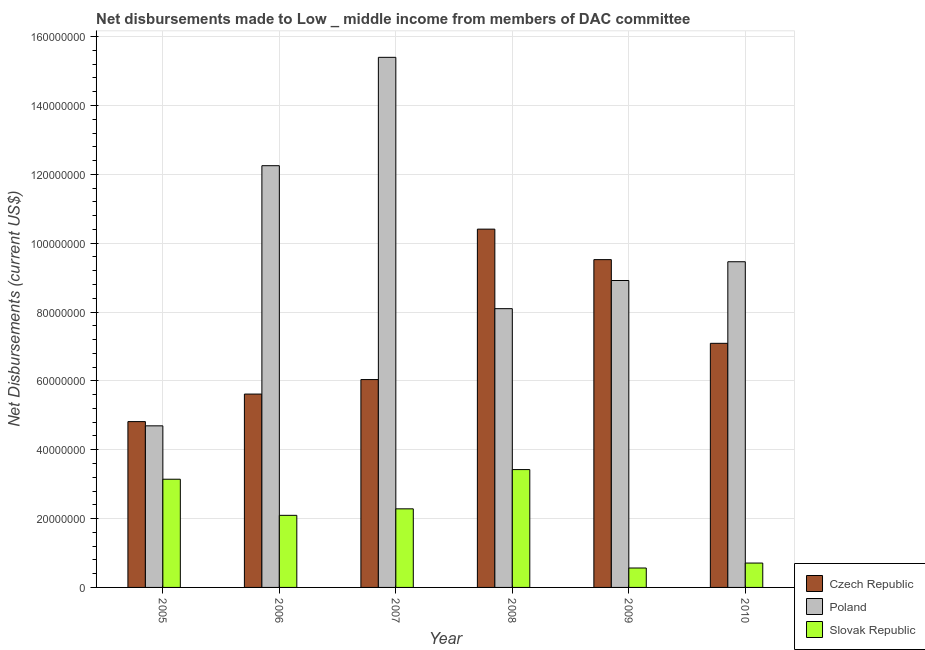Are the number of bars per tick equal to the number of legend labels?
Provide a short and direct response. Yes. Are the number of bars on each tick of the X-axis equal?
Your answer should be very brief. Yes. How many bars are there on the 5th tick from the left?
Give a very brief answer. 3. How many bars are there on the 1st tick from the right?
Your answer should be very brief. 3. What is the label of the 6th group of bars from the left?
Ensure brevity in your answer.  2010. What is the net disbursements made by poland in 2008?
Offer a terse response. 8.10e+07. Across all years, what is the maximum net disbursements made by poland?
Ensure brevity in your answer.  1.54e+08. Across all years, what is the minimum net disbursements made by poland?
Make the answer very short. 4.69e+07. In which year was the net disbursements made by czech republic maximum?
Keep it short and to the point. 2008. What is the total net disbursements made by czech republic in the graph?
Your answer should be compact. 4.35e+08. What is the difference between the net disbursements made by poland in 2009 and that in 2010?
Offer a very short reply. -5.45e+06. What is the difference between the net disbursements made by czech republic in 2010 and the net disbursements made by poland in 2007?
Your answer should be compact. 1.05e+07. What is the average net disbursements made by slovak republic per year?
Give a very brief answer. 2.04e+07. What is the ratio of the net disbursements made by slovak republic in 2008 to that in 2010?
Your response must be concise. 4.83. Is the net disbursements made by slovak republic in 2006 less than that in 2008?
Your answer should be compact. Yes. Is the difference between the net disbursements made by slovak republic in 2008 and 2009 greater than the difference between the net disbursements made by poland in 2008 and 2009?
Ensure brevity in your answer.  No. What is the difference between the highest and the second highest net disbursements made by poland?
Offer a terse response. 3.15e+07. What is the difference between the highest and the lowest net disbursements made by poland?
Keep it short and to the point. 1.07e+08. What does the 3rd bar from the left in 2009 represents?
Your answer should be very brief. Slovak Republic. What does the 3rd bar from the right in 2005 represents?
Provide a succinct answer. Czech Republic. Are all the bars in the graph horizontal?
Provide a short and direct response. No. Does the graph contain any zero values?
Make the answer very short. No. Where does the legend appear in the graph?
Keep it short and to the point. Bottom right. How many legend labels are there?
Your answer should be compact. 3. What is the title of the graph?
Give a very brief answer. Net disbursements made to Low _ middle income from members of DAC committee. What is the label or title of the Y-axis?
Your response must be concise. Net Disbursements (current US$). What is the Net Disbursements (current US$) in Czech Republic in 2005?
Your answer should be compact. 4.82e+07. What is the Net Disbursements (current US$) of Poland in 2005?
Your response must be concise. 4.69e+07. What is the Net Disbursements (current US$) of Slovak Republic in 2005?
Offer a terse response. 3.14e+07. What is the Net Disbursements (current US$) of Czech Republic in 2006?
Your answer should be very brief. 5.62e+07. What is the Net Disbursements (current US$) of Poland in 2006?
Offer a terse response. 1.23e+08. What is the Net Disbursements (current US$) of Slovak Republic in 2006?
Keep it short and to the point. 2.09e+07. What is the Net Disbursements (current US$) in Czech Republic in 2007?
Make the answer very short. 6.04e+07. What is the Net Disbursements (current US$) in Poland in 2007?
Your answer should be compact. 1.54e+08. What is the Net Disbursements (current US$) in Slovak Republic in 2007?
Ensure brevity in your answer.  2.28e+07. What is the Net Disbursements (current US$) of Czech Republic in 2008?
Give a very brief answer. 1.04e+08. What is the Net Disbursements (current US$) of Poland in 2008?
Give a very brief answer. 8.10e+07. What is the Net Disbursements (current US$) of Slovak Republic in 2008?
Keep it short and to the point. 3.42e+07. What is the Net Disbursements (current US$) of Czech Republic in 2009?
Offer a very short reply. 9.52e+07. What is the Net Disbursements (current US$) in Poland in 2009?
Make the answer very short. 8.92e+07. What is the Net Disbursements (current US$) in Slovak Republic in 2009?
Offer a terse response. 5.64e+06. What is the Net Disbursements (current US$) in Czech Republic in 2010?
Keep it short and to the point. 7.09e+07. What is the Net Disbursements (current US$) of Poland in 2010?
Make the answer very short. 9.46e+07. What is the Net Disbursements (current US$) of Slovak Republic in 2010?
Make the answer very short. 7.08e+06. Across all years, what is the maximum Net Disbursements (current US$) in Czech Republic?
Ensure brevity in your answer.  1.04e+08. Across all years, what is the maximum Net Disbursements (current US$) in Poland?
Your answer should be very brief. 1.54e+08. Across all years, what is the maximum Net Disbursements (current US$) of Slovak Republic?
Keep it short and to the point. 3.42e+07. Across all years, what is the minimum Net Disbursements (current US$) of Czech Republic?
Ensure brevity in your answer.  4.82e+07. Across all years, what is the minimum Net Disbursements (current US$) of Poland?
Provide a short and direct response. 4.69e+07. Across all years, what is the minimum Net Disbursements (current US$) of Slovak Republic?
Your answer should be very brief. 5.64e+06. What is the total Net Disbursements (current US$) in Czech Republic in the graph?
Provide a succinct answer. 4.35e+08. What is the total Net Disbursements (current US$) of Poland in the graph?
Your answer should be compact. 5.88e+08. What is the total Net Disbursements (current US$) in Slovak Republic in the graph?
Offer a very short reply. 1.22e+08. What is the difference between the Net Disbursements (current US$) in Czech Republic in 2005 and that in 2006?
Your answer should be very brief. -8.00e+06. What is the difference between the Net Disbursements (current US$) of Poland in 2005 and that in 2006?
Ensure brevity in your answer.  -7.56e+07. What is the difference between the Net Disbursements (current US$) in Slovak Republic in 2005 and that in 2006?
Offer a terse response. 1.05e+07. What is the difference between the Net Disbursements (current US$) in Czech Republic in 2005 and that in 2007?
Provide a succinct answer. -1.22e+07. What is the difference between the Net Disbursements (current US$) of Poland in 2005 and that in 2007?
Keep it short and to the point. -1.07e+08. What is the difference between the Net Disbursements (current US$) of Slovak Republic in 2005 and that in 2007?
Ensure brevity in your answer.  8.60e+06. What is the difference between the Net Disbursements (current US$) of Czech Republic in 2005 and that in 2008?
Keep it short and to the point. -5.59e+07. What is the difference between the Net Disbursements (current US$) in Poland in 2005 and that in 2008?
Your answer should be compact. -3.40e+07. What is the difference between the Net Disbursements (current US$) in Slovak Republic in 2005 and that in 2008?
Keep it short and to the point. -2.80e+06. What is the difference between the Net Disbursements (current US$) in Czech Republic in 2005 and that in 2009?
Your answer should be very brief. -4.70e+07. What is the difference between the Net Disbursements (current US$) of Poland in 2005 and that in 2009?
Give a very brief answer. -4.22e+07. What is the difference between the Net Disbursements (current US$) of Slovak Republic in 2005 and that in 2009?
Provide a succinct answer. 2.58e+07. What is the difference between the Net Disbursements (current US$) of Czech Republic in 2005 and that in 2010?
Provide a succinct answer. -2.27e+07. What is the difference between the Net Disbursements (current US$) in Poland in 2005 and that in 2010?
Make the answer very short. -4.77e+07. What is the difference between the Net Disbursements (current US$) of Slovak Republic in 2005 and that in 2010?
Your answer should be very brief. 2.44e+07. What is the difference between the Net Disbursements (current US$) of Czech Republic in 2006 and that in 2007?
Keep it short and to the point. -4.21e+06. What is the difference between the Net Disbursements (current US$) of Poland in 2006 and that in 2007?
Keep it short and to the point. -3.15e+07. What is the difference between the Net Disbursements (current US$) of Slovak Republic in 2006 and that in 2007?
Keep it short and to the point. -1.89e+06. What is the difference between the Net Disbursements (current US$) in Czech Republic in 2006 and that in 2008?
Make the answer very short. -4.79e+07. What is the difference between the Net Disbursements (current US$) of Poland in 2006 and that in 2008?
Ensure brevity in your answer.  4.15e+07. What is the difference between the Net Disbursements (current US$) in Slovak Republic in 2006 and that in 2008?
Offer a very short reply. -1.33e+07. What is the difference between the Net Disbursements (current US$) of Czech Republic in 2006 and that in 2009?
Provide a short and direct response. -3.90e+07. What is the difference between the Net Disbursements (current US$) of Poland in 2006 and that in 2009?
Your response must be concise. 3.34e+07. What is the difference between the Net Disbursements (current US$) in Slovak Republic in 2006 and that in 2009?
Your answer should be very brief. 1.53e+07. What is the difference between the Net Disbursements (current US$) in Czech Republic in 2006 and that in 2010?
Give a very brief answer. -1.47e+07. What is the difference between the Net Disbursements (current US$) of Poland in 2006 and that in 2010?
Keep it short and to the point. 2.79e+07. What is the difference between the Net Disbursements (current US$) of Slovak Republic in 2006 and that in 2010?
Make the answer very short. 1.39e+07. What is the difference between the Net Disbursements (current US$) of Czech Republic in 2007 and that in 2008?
Your answer should be very brief. -4.37e+07. What is the difference between the Net Disbursements (current US$) in Poland in 2007 and that in 2008?
Your answer should be compact. 7.30e+07. What is the difference between the Net Disbursements (current US$) in Slovak Republic in 2007 and that in 2008?
Offer a terse response. -1.14e+07. What is the difference between the Net Disbursements (current US$) in Czech Republic in 2007 and that in 2009?
Offer a terse response. -3.48e+07. What is the difference between the Net Disbursements (current US$) of Poland in 2007 and that in 2009?
Provide a succinct answer. 6.48e+07. What is the difference between the Net Disbursements (current US$) of Slovak Republic in 2007 and that in 2009?
Give a very brief answer. 1.72e+07. What is the difference between the Net Disbursements (current US$) of Czech Republic in 2007 and that in 2010?
Keep it short and to the point. -1.05e+07. What is the difference between the Net Disbursements (current US$) of Poland in 2007 and that in 2010?
Ensure brevity in your answer.  5.94e+07. What is the difference between the Net Disbursements (current US$) of Slovak Republic in 2007 and that in 2010?
Keep it short and to the point. 1.58e+07. What is the difference between the Net Disbursements (current US$) of Czech Republic in 2008 and that in 2009?
Your answer should be very brief. 8.86e+06. What is the difference between the Net Disbursements (current US$) in Poland in 2008 and that in 2009?
Your answer should be compact. -8.18e+06. What is the difference between the Net Disbursements (current US$) of Slovak Republic in 2008 and that in 2009?
Keep it short and to the point. 2.86e+07. What is the difference between the Net Disbursements (current US$) of Czech Republic in 2008 and that in 2010?
Provide a succinct answer. 3.32e+07. What is the difference between the Net Disbursements (current US$) of Poland in 2008 and that in 2010?
Give a very brief answer. -1.36e+07. What is the difference between the Net Disbursements (current US$) of Slovak Republic in 2008 and that in 2010?
Keep it short and to the point. 2.72e+07. What is the difference between the Net Disbursements (current US$) in Czech Republic in 2009 and that in 2010?
Make the answer very short. 2.43e+07. What is the difference between the Net Disbursements (current US$) of Poland in 2009 and that in 2010?
Your answer should be compact. -5.45e+06. What is the difference between the Net Disbursements (current US$) in Slovak Republic in 2009 and that in 2010?
Your answer should be very brief. -1.44e+06. What is the difference between the Net Disbursements (current US$) of Czech Republic in 2005 and the Net Disbursements (current US$) of Poland in 2006?
Your answer should be very brief. -7.43e+07. What is the difference between the Net Disbursements (current US$) in Czech Republic in 2005 and the Net Disbursements (current US$) in Slovak Republic in 2006?
Make the answer very short. 2.72e+07. What is the difference between the Net Disbursements (current US$) of Poland in 2005 and the Net Disbursements (current US$) of Slovak Republic in 2006?
Your response must be concise. 2.60e+07. What is the difference between the Net Disbursements (current US$) of Czech Republic in 2005 and the Net Disbursements (current US$) of Poland in 2007?
Ensure brevity in your answer.  -1.06e+08. What is the difference between the Net Disbursements (current US$) of Czech Republic in 2005 and the Net Disbursements (current US$) of Slovak Republic in 2007?
Ensure brevity in your answer.  2.53e+07. What is the difference between the Net Disbursements (current US$) in Poland in 2005 and the Net Disbursements (current US$) in Slovak Republic in 2007?
Your answer should be very brief. 2.41e+07. What is the difference between the Net Disbursements (current US$) in Czech Republic in 2005 and the Net Disbursements (current US$) in Poland in 2008?
Give a very brief answer. -3.28e+07. What is the difference between the Net Disbursements (current US$) of Czech Republic in 2005 and the Net Disbursements (current US$) of Slovak Republic in 2008?
Your response must be concise. 1.39e+07. What is the difference between the Net Disbursements (current US$) in Poland in 2005 and the Net Disbursements (current US$) in Slovak Republic in 2008?
Your response must be concise. 1.27e+07. What is the difference between the Net Disbursements (current US$) of Czech Republic in 2005 and the Net Disbursements (current US$) of Poland in 2009?
Provide a short and direct response. -4.10e+07. What is the difference between the Net Disbursements (current US$) in Czech Republic in 2005 and the Net Disbursements (current US$) in Slovak Republic in 2009?
Keep it short and to the point. 4.25e+07. What is the difference between the Net Disbursements (current US$) in Poland in 2005 and the Net Disbursements (current US$) in Slovak Republic in 2009?
Your response must be concise. 4.13e+07. What is the difference between the Net Disbursements (current US$) of Czech Republic in 2005 and the Net Disbursements (current US$) of Poland in 2010?
Ensure brevity in your answer.  -4.64e+07. What is the difference between the Net Disbursements (current US$) of Czech Republic in 2005 and the Net Disbursements (current US$) of Slovak Republic in 2010?
Ensure brevity in your answer.  4.11e+07. What is the difference between the Net Disbursements (current US$) in Poland in 2005 and the Net Disbursements (current US$) in Slovak Republic in 2010?
Your answer should be very brief. 3.99e+07. What is the difference between the Net Disbursements (current US$) of Czech Republic in 2006 and the Net Disbursements (current US$) of Poland in 2007?
Ensure brevity in your answer.  -9.78e+07. What is the difference between the Net Disbursements (current US$) of Czech Republic in 2006 and the Net Disbursements (current US$) of Slovak Republic in 2007?
Offer a very short reply. 3.33e+07. What is the difference between the Net Disbursements (current US$) of Poland in 2006 and the Net Disbursements (current US$) of Slovak Republic in 2007?
Ensure brevity in your answer.  9.97e+07. What is the difference between the Net Disbursements (current US$) of Czech Republic in 2006 and the Net Disbursements (current US$) of Poland in 2008?
Ensure brevity in your answer.  -2.48e+07. What is the difference between the Net Disbursements (current US$) of Czech Republic in 2006 and the Net Disbursements (current US$) of Slovak Republic in 2008?
Offer a terse response. 2.19e+07. What is the difference between the Net Disbursements (current US$) of Poland in 2006 and the Net Disbursements (current US$) of Slovak Republic in 2008?
Offer a terse response. 8.83e+07. What is the difference between the Net Disbursements (current US$) in Czech Republic in 2006 and the Net Disbursements (current US$) in Poland in 2009?
Keep it short and to the point. -3.30e+07. What is the difference between the Net Disbursements (current US$) of Czech Republic in 2006 and the Net Disbursements (current US$) of Slovak Republic in 2009?
Provide a succinct answer. 5.05e+07. What is the difference between the Net Disbursements (current US$) in Poland in 2006 and the Net Disbursements (current US$) in Slovak Republic in 2009?
Your response must be concise. 1.17e+08. What is the difference between the Net Disbursements (current US$) in Czech Republic in 2006 and the Net Disbursements (current US$) in Poland in 2010?
Keep it short and to the point. -3.84e+07. What is the difference between the Net Disbursements (current US$) in Czech Republic in 2006 and the Net Disbursements (current US$) in Slovak Republic in 2010?
Provide a succinct answer. 4.91e+07. What is the difference between the Net Disbursements (current US$) of Poland in 2006 and the Net Disbursements (current US$) of Slovak Republic in 2010?
Make the answer very short. 1.15e+08. What is the difference between the Net Disbursements (current US$) in Czech Republic in 2007 and the Net Disbursements (current US$) in Poland in 2008?
Give a very brief answer. -2.06e+07. What is the difference between the Net Disbursements (current US$) of Czech Republic in 2007 and the Net Disbursements (current US$) of Slovak Republic in 2008?
Make the answer very short. 2.62e+07. What is the difference between the Net Disbursements (current US$) in Poland in 2007 and the Net Disbursements (current US$) in Slovak Republic in 2008?
Offer a terse response. 1.20e+08. What is the difference between the Net Disbursements (current US$) in Czech Republic in 2007 and the Net Disbursements (current US$) in Poland in 2009?
Keep it short and to the point. -2.88e+07. What is the difference between the Net Disbursements (current US$) of Czech Republic in 2007 and the Net Disbursements (current US$) of Slovak Republic in 2009?
Provide a succinct answer. 5.47e+07. What is the difference between the Net Disbursements (current US$) in Poland in 2007 and the Net Disbursements (current US$) in Slovak Republic in 2009?
Offer a very short reply. 1.48e+08. What is the difference between the Net Disbursements (current US$) in Czech Republic in 2007 and the Net Disbursements (current US$) in Poland in 2010?
Your response must be concise. -3.42e+07. What is the difference between the Net Disbursements (current US$) of Czech Republic in 2007 and the Net Disbursements (current US$) of Slovak Republic in 2010?
Provide a succinct answer. 5.33e+07. What is the difference between the Net Disbursements (current US$) of Poland in 2007 and the Net Disbursements (current US$) of Slovak Republic in 2010?
Offer a very short reply. 1.47e+08. What is the difference between the Net Disbursements (current US$) in Czech Republic in 2008 and the Net Disbursements (current US$) in Poland in 2009?
Provide a succinct answer. 1.49e+07. What is the difference between the Net Disbursements (current US$) in Czech Republic in 2008 and the Net Disbursements (current US$) in Slovak Republic in 2009?
Offer a very short reply. 9.84e+07. What is the difference between the Net Disbursements (current US$) of Poland in 2008 and the Net Disbursements (current US$) of Slovak Republic in 2009?
Offer a terse response. 7.53e+07. What is the difference between the Net Disbursements (current US$) in Czech Republic in 2008 and the Net Disbursements (current US$) in Poland in 2010?
Give a very brief answer. 9.47e+06. What is the difference between the Net Disbursements (current US$) in Czech Republic in 2008 and the Net Disbursements (current US$) in Slovak Republic in 2010?
Your response must be concise. 9.70e+07. What is the difference between the Net Disbursements (current US$) in Poland in 2008 and the Net Disbursements (current US$) in Slovak Republic in 2010?
Keep it short and to the point. 7.39e+07. What is the difference between the Net Disbursements (current US$) of Czech Republic in 2009 and the Net Disbursements (current US$) of Slovak Republic in 2010?
Provide a short and direct response. 8.81e+07. What is the difference between the Net Disbursements (current US$) in Poland in 2009 and the Net Disbursements (current US$) in Slovak Republic in 2010?
Provide a short and direct response. 8.21e+07. What is the average Net Disbursements (current US$) of Czech Republic per year?
Your answer should be compact. 7.25e+07. What is the average Net Disbursements (current US$) of Poland per year?
Your response must be concise. 9.80e+07. What is the average Net Disbursements (current US$) of Slovak Republic per year?
Ensure brevity in your answer.  2.04e+07. In the year 2005, what is the difference between the Net Disbursements (current US$) in Czech Republic and Net Disbursements (current US$) in Poland?
Keep it short and to the point. 1.23e+06. In the year 2005, what is the difference between the Net Disbursements (current US$) of Czech Republic and Net Disbursements (current US$) of Slovak Republic?
Your answer should be very brief. 1.67e+07. In the year 2005, what is the difference between the Net Disbursements (current US$) in Poland and Net Disbursements (current US$) in Slovak Republic?
Provide a succinct answer. 1.55e+07. In the year 2006, what is the difference between the Net Disbursements (current US$) in Czech Republic and Net Disbursements (current US$) in Poland?
Your answer should be compact. -6.63e+07. In the year 2006, what is the difference between the Net Disbursements (current US$) in Czech Republic and Net Disbursements (current US$) in Slovak Republic?
Provide a short and direct response. 3.52e+07. In the year 2006, what is the difference between the Net Disbursements (current US$) of Poland and Net Disbursements (current US$) of Slovak Republic?
Give a very brief answer. 1.02e+08. In the year 2007, what is the difference between the Net Disbursements (current US$) in Czech Republic and Net Disbursements (current US$) in Poland?
Keep it short and to the point. -9.36e+07. In the year 2007, what is the difference between the Net Disbursements (current US$) in Czech Republic and Net Disbursements (current US$) in Slovak Republic?
Your answer should be very brief. 3.76e+07. In the year 2007, what is the difference between the Net Disbursements (current US$) in Poland and Net Disbursements (current US$) in Slovak Republic?
Your response must be concise. 1.31e+08. In the year 2008, what is the difference between the Net Disbursements (current US$) of Czech Republic and Net Disbursements (current US$) of Poland?
Provide a succinct answer. 2.31e+07. In the year 2008, what is the difference between the Net Disbursements (current US$) of Czech Republic and Net Disbursements (current US$) of Slovak Republic?
Your answer should be very brief. 6.98e+07. In the year 2008, what is the difference between the Net Disbursements (current US$) in Poland and Net Disbursements (current US$) in Slovak Republic?
Offer a terse response. 4.68e+07. In the year 2009, what is the difference between the Net Disbursements (current US$) of Czech Republic and Net Disbursements (current US$) of Poland?
Ensure brevity in your answer.  6.06e+06. In the year 2009, what is the difference between the Net Disbursements (current US$) in Czech Republic and Net Disbursements (current US$) in Slovak Republic?
Provide a short and direct response. 8.96e+07. In the year 2009, what is the difference between the Net Disbursements (current US$) of Poland and Net Disbursements (current US$) of Slovak Republic?
Provide a short and direct response. 8.35e+07. In the year 2010, what is the difference between the Net Disbursements (current US$) of Czech Republic and Net Disbursements (current US$) of Poland?
Ensure brevity in your answer.  -2.37e+07. In the year 2010, what is the difference between the Net Disbursements (current US$) of Czech Republic and Net Disbursements (current US$) of Slovak Republic?
Provide a succinct answer. 6.38e+07. In the year 2010, what is the difference between the Net Disbursements (current US$) of Poland and Net Disbursements (current US$) of Slovak Republic?
Your answer should be very brief. 8.75e+07. What is the ratio of the Net Disbursements (current US$) of Czech Republic in 2005 to that in 2006?
Keep it short and to the point. 0.86. What is the ratio of the Net Disbursements (current US$) of Poland in 2005 to that in 2006?
Your answer should be very brief. 0.38. What is the ratio of the Net Disbursements (current US$) of Slovak Republic in 2005 to that in 2006?
Offer a very short reply. 1.5. What is the ratio of the Net Disbursements (current US$) of Czech Republic in 2005 to that in 2007?
Your answer should be compact. 0.8. What is the ratio of the Net Disbursements (current US$) in Poland in 2005 to that in 2007?
Your response must be concise. 0.3. What is the ratio of the Net Disbursements (current US$) of Slovak Republic in 2005 to that in 2007?
Offer a terse response. 1.38. What is the ratio of the Net Disbursements (current US$) in Czech Republic in 2005 to that in 2008?
Your response must be concise. 0.46. What is the ratio of the Net Disbursements (current US$) of Poland in 2005 to that in 2008?
Keep it short and to the point. 0.58. What is the ratio of the Net Disbursements (current US$) in Slovak Republic in 2005 to that in 2008?
Ensure brevity in your answer.  0.92. What is the ratio of the Net Disbursements (current US$) of Czech Republic in 2005 to that in 2009?
Provide a succinct answer. 0.51. What is the ratio of the Net Disbursements (current US$) of Poland in 2005 to that in 2009?
Your response must be concise. 0.53. What is the ratio of the Net Disbursements (current US$) of Slovak Republic in 2005 to that in 2009?
Make the answer very short. 5.57. What is the ratio of the Net Disbursements (current US$) in Czech Republic in 2005 to that in 2010?
Your answer should be very brief. 0.68. What is the ratio of the Net Disbursements (current US$) of Poland in 2005 to that in 2010?
Provide a short and direct response. 0.5. What is the ratio of the Net Disbursements (current US$) in Slovak Republic in 2005 to that in 2010?
Ensure brevity in your answer.  4.44. What is the ratio of the Net Disbursements (current US$) in Czech Republic in 2006 to that in 2007?
Provide a succinct answer. 0.93. What is the ratio of the Net Disbursements (current US$) in Poland in 2006 to that in 2007?
Your response must be concise. 0.8. What is the ratio of the Net Disbursements (current US$) in Slovak Republic in 2006 to that in 2007?
Offer a very short reply. 0.92. What is the ratio of the Net Disbursements (current US$) of Czech Republic in 2006 to that in 2008?
Ensure brevity in your answer.  0.54. What is the ratio of the Net Disbursements (current US$) in Poland in 2006 to that in 2008?
Your response must be concise. 1.51. What is the ratio of the Net Disbursements (current US$) of Slovak Republic in 2006 to that in 2008?
Provide a succinct answer. 0.61. What is the ratio of the Net Disbursements (current US$) of Czech Republic in 2006 to that in 2009?
Your answer should be very brief. 0.59. What is the ratio of the Net Disbursements (current US$) of Poland in 2006 to that in 2009?
Give a very brief answer. 1.37. What is the ratio of the Net Disbursements (current US$) of Slovak Republic in 2006 to that in 2009?
Your answer should be compact. 3.71. What is the ratio of the Net Disbursements (current US$) of Czech Republic in 2006 to that in 2010?
Provide a short and direct response. 0.79. What is the ratio of the Net Disbursements (current US$) of Poland in 2006 to that in 2010?
Ensure brevity in your answer.  1.29. What is the ratio of the Net Disbursements (current US$) of Slovak Republic in 2006 to that in 2010?
Your answer should be very brief. 2.96. What is the ratio of the Net Disbursements (current US$) of Czech Republic in 2007 to that in 2008?
Provide a succinct answer. 0.58. What is the ratio of the Net Disbursements (current US$) of Poland in 2007 to that in 2008?
Your response must be concise. 1.9. What is the ratio of the Net Disbursements (current US$) in Slovak Republic in 2007 to that in 2008?
Your answer should be very brief. 0.67. What is the ratio of the Net Disbursements (current US$) of Czech Republic in 2007 to that in 2009?
Your response must be concise. 0.63. What is the ratio of the Net Disbursements (current US$) of Poland in 2007 to that in 2009?
Give a very brief answer. 1.73. What is the ratio of the Net Disbursements (current US$) in Slovak Republic in 2007 to that in 2009?
Your answer should be very brief. 4.05. What is the ratio of the Net Disbursements (current US$) in Czech Republic in 2007 to that in 2010?
Your response must be concise. 0.85. What is the ratio of the Net Disbursements (current US$) of Poland in 2007 to that in 2010?
Your response must be concise. 1.63. What is the ratio of the Net Disbursements (current US$) in Slovak Republic in 2007 to that in 2010?
Offer a terse response. 3.22. What is the ratio of the Net Disbursements (current US$) in Czech Republic in 2008 to that in 2009?
Your answer should be very brief. 1.09. What is the ratio of the Net Disbursements (current US$) of Poland in 2008 to that in 2009?
Provide a succinct answer. 0.91. What is the ratio of the Net Disbursements (current US$) in Slovak Republic in 2008 to that in 2009?
Your answer should be very brief. 6.07. What is the ratio of the Net Disbursements (current US$) of Czech Republic in 2008 to that in 2010?
Offer a very short reply. 1.47. What is the ratio of the Net Disbursements (current US$) of Poland in 2008 to that in 2010?
Ensure brevity in your answer.  0.86. What is the ratio of the Net Disbursements (current US$) of Slovak Republic in 2008 to that in 2010?
Your answer should be very brief. 4.83. What is the ratio of the Net Disbursements (current US$) of Czech Republic in 2009 to that in 2010?
Ensure brevity in your answer.  1.34. What is the ratio of the Net Disbursements (current US$) of Poland in 2009 to that in 2010?
Offer a very short reply. 0.94. What is the ratio of the Net Disbursements (current US$) of Slovak Republic in 2009 to that in 2010?
Provide a short and direct response. 0.8. What is the difference between the highest and the second highest Net Disbursements (current US$) of Czech Republic?
Offer a terse response. 8.86e+06. What is the difference between the highest and the second highest Net Disbursements (current US$) in Poland?
Provide a short and direct response. 3.15e+07. What is the difference between the highest and the second highest Net Disbursements (current US$) of Slovak Republic?
Make the answer very short. 2.80e+06. What is the difference between the highest and the lowest Net Disbursements (current US$) in Czech Republic?
Keep it short and to the point. 5.59e+07. What is the difference between the highest and the lowest Net Disbursements (current US$) in Poland?
Your response must be concise. 1.07e+08. What is the difference between the highest and the lowest Net Disbursements (current US$) in Slovak Republic?
Your answer should be very brief. 2.86e+07. 